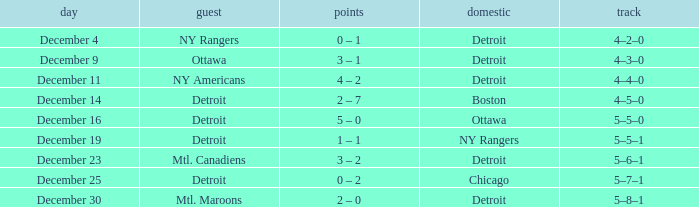What visitor has December 14 as the date? Detroit. Could you parse the entire table as a dict? {'header': ['day', 'guest', 'points', 'domestic', 'track'], 'rows': [['December 4', 'NY Rangers', '0 – 1', 'Detroit', '4–2–0'], ['December 9', 'Ottawa', '3 – 1', 'Detroit', '4–3–0'], ['December 11', 'NY Americans', '4 – 2', 'Detroit', '4–4–0'], ['December 14', 'Detroit', '2 – 7', 'Boston', '4–5–0'], ['December 16', 'Detroit', '5 – 0', 'Ottawa', '5–5–0'], ['December 19', 'Detroit', '1 – 1', 'NY Rangers', '5–5–1'], ['December 23', 'Mtl. Canadiens', '3 – 2', 'Detroit', '5–6–1'], ['December 25', 'Detroit', '0 – 2', 'Chicago', '5–7–1'], ['December 30', 'Mtl. Maroons', '2 – 0', 'Detroit', '5–8–1']]} 